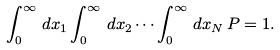Convert formula to latex. <formula><loc_0><loc_0><loc_500><loc_500>\int _ { 0 } ^ { \infty } \, d x _ { 1 } \int _ { 0 } ^ { \infty } \, d x _ { 2 } \cdots \int _ { 0 } ^ { \infty } \, d x _ { N } \, P = 1 .</formula> 